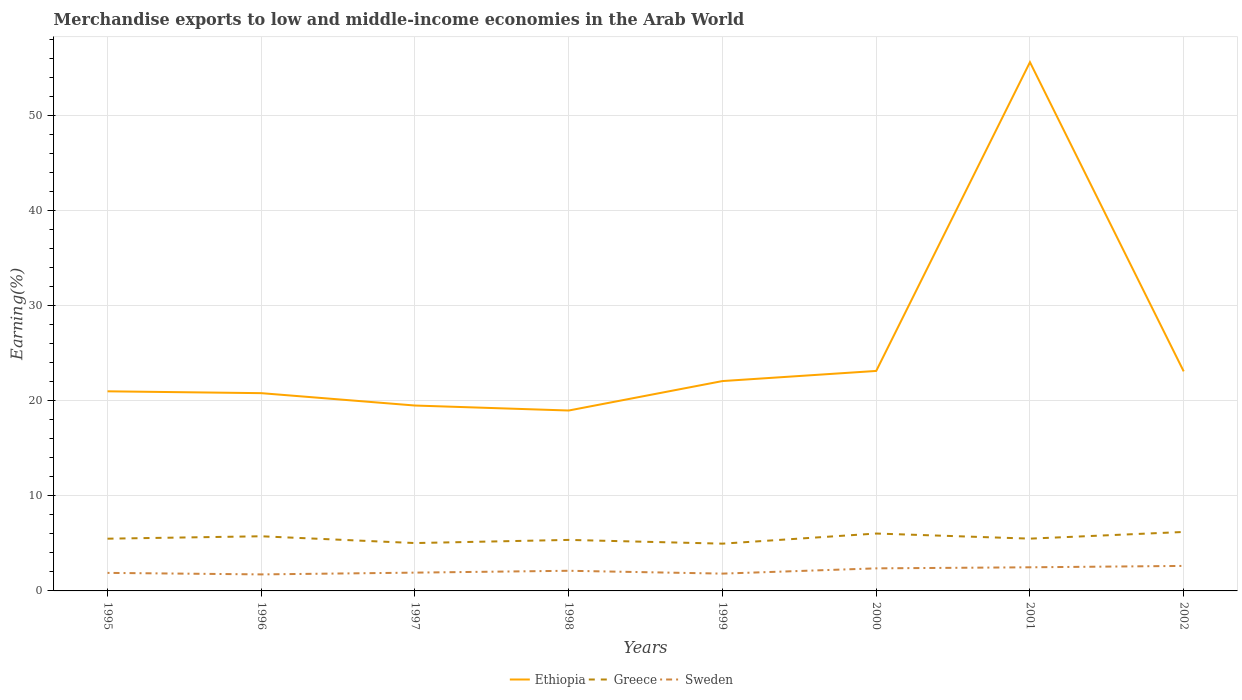Is the number of lines equal to the number of legend labels?
Make the answer very short. Yes. Across all years, what is the maximum percentage of amount earned from merchandise exports in Greece?
Give a very brief answer. 4.97. In which year was the percentage of amount earned from merchandise exports in Sweden maximum?
Ensure brevity in your answer.  1996. What is the total percentage of amount earned from merchandise exports in Sweden in the graph?
Offer a very short reply. -0.25. What is the difference between the highest and the second highest percentage of amount earned from merchandise exports in Ethiopia?
Give a very brief answer. 36.65. Is the percentage of amount earned from merchandise exports in Sweden strictly greater than the percentage of amount earned from merchandise exports in Ethiopia over the years?
Give a very brief answer. Yes. Does the graph contain any zero values?
Keep it short and to the point. No. Does the graph contain grids?
Keep it short and to the point. Yes. How many legend labels are there?
Provide a succinct answer. 3. What is the title of the graph?
Provide a short and direct response. Merchandise exports to low and middle-income economies in the Arab World. Does "Panama" appear as one of the legend labels in the graph?
Give a very brief answer. No. What is the label or title of the X-axis?
Offer a terse response. Years. What is the label or title of the Y-axis?
Offer a very short reply. Earning(%). What is the Earning(%) in Ethiopia in 1995?
Your answer should be compact. 21. What is the Earning(%) of Greece in 1995?
Offer a terse response. 5.5. What is the Earning(%) of Sweden in 1995?
Your answer should be very brief. 1.9. What is the Earning(%) in Ethiopia in 1996?
Make the answer very short. 20.81. What is the Earning(%) of Greece in 1996?
Your response must be concise. 5.75. What is the Earning(%) in Sweden in 1996?
Your response must be concise. 1.74. What is the Earning(%) of Ethiopia in 1997?
Provide a short and direct response. 19.51. What is the Earning(%) in Greece in 1997?
Offer a terse response. 5.04. What is the Earning(%) of Sweden in 1997?
Offer a terse response. 1.93. What is the Earning(%) in Ethiopia in 1998?
Keep it short and to the point. 18.98. What is the Earning(%) in Greece in 1998?
Give a very brief answer. 5.37. What is the Earning(%) of Sweden in 1998?
Provide a short and direct response. 2.12. What is the Earning(%) of Ethiopia in 1999?
Your answer should be compact. 22.08. What is the Earning(%) of Greece in 1999?
Offer a terse response. 4.97. What is the Earning(%) of Sweden in 1999?
Offer a terse response. 1.82. What is the Earning(%) in Ethiopia in 2000?
Keep it short and to the point. 23.15. What is the Earning(%) in Greece in 2000?
Provide a succinct answer. 6.04. What is the Earning(%) in Sweden in 2000?
Ensure brevity in your answer.  2.37. What is the Earning(%) of Ethiopia in 2001?
Your answer should be very brief. 55.64. What is the Earning(%) of Greece in 2001?
Provide a succinct answer. 5.5. What is the Earning(%) of Sweden in 2001?
Provide a short and direct response. 2.49. What is the Earning(%) of Ethiopia in 2002?
Your response must be concise. 23.1. What is the Earning(%) in Greece in 2002?
Offer a terse response. 6.2. What is the Earning(%) of Sweden in 2002?
Ensure brevity in your answer.  2.63. Across all years, what is the maximum Earning(%) of Ethiopia?
Keep it short and to the point. 55.64. Across all years, what is the maximum Earning(%) in Greece?
Your answer should be compact. 6.2. Across all years, what is the maximum Earning(%) of Sweden?
Provide a succinct answer. 2.63. Across all years, what is the minimum Earning(%) of Ethiopia?
Provide a short and direct response. 18.98. Across all years, what is the minimum Earning(%) in Greece?
Offer a very short reply. 4.97. Across all years, what is the minimum Earning(%) in Sweden?
Offer a terse response. 1.74. What is the total Earning(%) of Ethiopia in the graph?
Make the answer very short. 204.28. What is the total Earning(%) of Greece in the graph?
Your answer should be very brief. 44.37. What is the total Earning(%) of Sweden in the graph?
Your answer should be very brief. 17. What is the difference between the Earning(%) of Ethiopia in 1995 and that in 1996?
Provide a succinct answer. 0.19. What is the difference between the Earning(%) of Greece in 1995 and that in 1996?
Provide a succinct answer. -0.25. What is the difference between the Earning(%) of Sweden in 1995 and that in 1996?
Keep it short and to the point. 0.16. What is the difference between the Earning(%) in Ethiopia in 1995 and that in 1997?
Keep it short and to the point. 1.5. What is the difference between the Earning(%) of Greece in 1995 and that in 1997?
Offer a very short reply. 0.46. What is the difference between the Earning(%) of Sweden in 1995 and that in 1997?
Give a very brief answer. -0.03. What is the difference between the Earning(%) in Ethiopia in 1995 and that in 1998?
Your response must be concise. 2.02. What is the difference between the Earning(%) in Greece in 1995 and that in 1998?
Keep it short and to the point. 0.13. What is the difference between the Earning(%) in Sweden in 1995 and that in 1998?
Your response must be concise. -0.22. What is the difference between the Earning(%) of Ethiopia in 1995 and that in 1999?
Keep it short and to the point. -1.08. What is the difference between the Earning(%) of Greece in 1995 and that in 1999?
Ensure brevity in your answer.  0.52. What is the difference between the Earning(%) of Sweden in 1995 and that in 1999?
Provide a succinct answer. 0.08. What is the difference between the Earning(%) in Ethiopia in 1995 and that in 2000?
Make the answer very short. -2.14. What is the difference between the Earning(%) in Greece in 1995 and that in 2000?
Offer a very short reply. -0.54. What is the difference between the Earning(%) in Sweden in 1995 and that in 2000?
Offer a terse response. -0.48. What is the difference between the Earning(%) in Ethiopia in 1995 and that in 2001?
Ensure brevity in your answer.  -34.63. What is the difference between the Earning(%) of Greece in 1995 and that in 2001?
Your response must be concise. -0. What is the difference between the Earning(%) in Sweden in 1995 and that in 2001?
Keep it short and to the point. -0.59. What is the difference between the Earning(%) of Ethiopia in 1995 and that in 2002?
Offer a terse response. -2.1. What is the difference between the Earning(%) of Greece in 1995 and that in 2002?
Offer a very short reply. -0.71. What is the difference between the Earning(%) in Sweden in 1995 and that in 2002?
Your response must be concise. -0.73. What is the difference between the Earning(%) in Ethiopia in 1996 and that in 1997?
Provide a short and direct response. 1.3. What is the difference between the Earning(%) in Greece in 1996 and that in 1997?
Your answer should be compact. 0.71. What is the difference between the Earning(%) in Sweden in 1996 and that in 1997?
Keep it short and to the point. -0.19. What is the difference between the Earning(%) in Ethiopia in 1996 and that in 1998?
Offer a very short reply. 1.83. What is the difference between the Earning(%) in Greece in 1996 and that in 1998?
Make the answer very short. 0.38. What is the difference between the Earning(%) of Sweden in 1996 and that in 1998?
Give a very brief answer. -0.38. What is the difference between the Earning(%) in Ethiopia in 1996 and that in 1999?
Your answer should be very brief. -1.27. What is the difference between the Earning(%) of Greece in 1996 and that in 1999?
Your response must be concise. 0.78. What is the difference between the Earning(%) in Sweden in 1996 and that in 1999?
Give a very brief answer. -0.08. What is the difference between the Earning(%) in Ethiopia in 1996 and that in 2000?
Your answer should be very brief. -2.34. What is the difference between the Earning(%) in Greece in 1996 and that in 2000?
Keep it short and to the point. -0.29. What is the difference between the Earning(%) in Sweden in 1996 and that in 2000?
Your answer should be compact. -0.64. What is the difference between the Earning(%) of Ethiopia in 1996 and that in 2001?
Give a very brief answer. -34.83. What is the difference between the Earning(%) in Greece in 1996 and that in 2001?
Provide a succinct answer. 0.25. What is the difference between the Earning(%) in Sweden in 1996 and that in 2001?
Make the answer very short. -0.75. What is the difference between the Earning(%) in Ethiopia in 1996 and that in 2002?
Provide a succinct answer. -2.29. What is the difference between the Earning(%) of Greece in 1996 and that in 2002?
Ensure brevity in your answer.  -0.45. What is the difference between the Earning(%) of Sweden in 1996 and that in 2002?
Provide a short and direct response. -0.89. What is the difference between the Earning(%) of Ethiopia in 1997 and that in 1998?
Your response must be concise. 0.52. What is the difference between the Earning(%) in Greece in 1997 and that in 1998?
Give a very brief answer. -0.33. What is the difference between the Earning(%) of Sweden in 1997 and that in 1998?
Ensure brevity in your answer.  -0.2. What is the difference between the Earning(%) in Ethiopia in 1997 and that in 1999?
Ensure brevity in your answer.  -2.57. What is the difference between the Earning(%) in Greece in 1997 and that in 1999?
Offer a very short reply. 0.06. What is the difference between the Earning(%) in Sweden in 1997 and that in 1999?
Your answer should be very brief. 0.1. What is the difference between the Earning(%) in Ethiopia in 1997 and that in 2000?
Give a very brief answer. -3.64. What is the difference between the Earning(%) of Greece in 1997 and that in 2000?
Offer a terse response. -1. What is the difference between the Earning(%) of Sweden in 1997 and that in 2000?
Keep it short and to the point. -0.45. What is the difference between the Earning(%) in Ethiopia in 1997 and that in 2001?
Ensure brevity in your answer.  -36.13. What is the difference between the Earning(%) of Greece in 1997 and that in 2001?
Provide a succinct answer. -0.47. What is the difference between the Earning(%) in Sweden in 1997 and that in 2001?
Your answer should be compact. -0.56. What is the difference between the Earning(%) in Ethiopia in 1997 and that in 2002?
Your response must be concise. -3.59. What is the difference between the Earning(%) of Greece in 1997 and that in 2002?
Make the answer very short. -1.17. What is the difference between the Earning(%) in Sweden in 1997 and that in 2002?
Your answer should be very brief. -0.71. What is the difference between the Earning(%) of Ethiopia in 1998 and that in 1999?
Provide a short and direct response. -3.1. What is the difference between the Earning(%) in Greece in 1998 and that in 1999?
Provide a short and direct response. 0.4. What is the difference between the Earning(%) of Sweden in 1998 and that in 1999?
Provide a short and direct response. 0.3. What is the difference between the Earning(%) in Ethiopia in 1998 and that in 2000?
Your answer should be very brief. -4.16. What is the difference between the Earning(%) of Greece in 1998 and that in 2000?
Your answer should be compact. -0.67. What is the difference between the Earning(%) of Sweden in 1998 and that in 2000?
Offer a terse response. -0.25. What is the difference between the Earning(%) of Ethiopia in 1998 and that in 2001?
Your response must be concise. -36.65. What is the difference between the Earning(%) of Greece in 1998 and that in 2001?
Your answer should be compact. -0.13. What is the difference between the Earning(%) of Sweden in 1998 and that in 2001?
Your answer should be very brief. -0.37. What is the difference between the Earning(%) in Ethiopia in 1998 and that in 2002?
Give a very brief answer. -4.12. What is the difference between the Earning(%) in Greece in 1998 and that in 2002?
Provide a short and direct response. -0.84. What is the difference between the Earning(%) in Sweden in 1998 and that in 2002?
Offer a terse response. -0.51. What is the difference between the Earning(%) in Ethiopia in 1999 and that in 2000?
Provide a succinct answer. -1.07. What is the difference between the Earning(%) of Greece in 1999 and that in 2000?
Keep it short and to the point. -1.07. What is the difference between the Earning(%) in Sweden in 1999 and that in 2000?
Make the answer very short. -0.55. What is the difference between the Earning(%) of Ethiopia in 1999 and that in 2001?
Offer a terse response. -33.56. What is the difference between the Earning(%) of Greece in 1999 and that in 2001?
Keep it short and to the point. -0.53. What is the difference between the Earning(%) in Sweden in 1999 and that in 2001?
Keep it short and to the point. -0.67. What is the difference between the Earning(%) of Ethiopia in 1999 and that in 2002?
Your response must be concise. -1.02. What is the difference between the Earning(%) of Greece in 1999 and that in 2002?
Give a very brief answer. -1.23. What is the difference between the Earning(%) of Sweden in 1999 and that in 2002?
Offer a very short reply. -0.81. What is the difference between the Earning(%) in Ethiopia in 2000 and that in 2001?
Keep it short and to the point. -32.49. What is the difference between the Earning(%) of Greece in 2000 and that in 2001?
Make the answer very short. 0.54. What is the difference between the Earning(%) of Sweden in 2000 and that in 2001?
Your response must be concise. -0.11. What is the difference between the Earning(%) in Ethiopia in 2000 and that in 2002?
Provide a succinct answer. 0.05. What is the difference between the Earning(%) in Greece in 2000 and that in 2002?
Provide a succinct answer. -0.17. What is the difference between the Earning(%) of Sweden in 2000 and that in 2002?
Keep it short and to the point. -0.26. What is the difference between the Earning(%) in Ethiopia in 2001 and that in 2002?
Make the answer very short. 32.53. What is the difference between the Earning(%) in Greece in 2001 and that in 2002?
Give a very brief answer. -0.7. What is the difference between the Earning(%) of Sweden in 2001 and that in 2002?
Give a very brief answer. -0.15. What is the difference between the Earning(%) in Ethiopia in 1995 and the Earning(%) in Greece in 1996?
Offer a very short reply. 15.25. What is the difference between the Earning(%) in Ethiopia in 1995 and the Earning(%) in Sweden in 1996?
Offer a very short reply. 19.27. What is the difference between the Earning(%) in Greece in 1995 and the Earning(%) in Sweden in 1996?
Offer a very short reply. 3.76. What is the difference between the Earning(%) of Ethiopia in 1995 and the Earning(%) of Greece in 1997?
Your answer should be very brief. 15.97. What is the difference between the Earning(%) of Ethiopia in 1995 and the Earning(%) of Sweden in 1997?
Your answer should be compact. 19.08. What is the difference between the Earning(%) in Greece in 1995 and the Earning(%) in Sweden in 1997?
Give a very brief answer. 3.57. What is the difference between the Earning(%) in Ethiopia in 1995 and the Earning(%) in Greece in 1998?
Your answer should be compact. 15.64. What is the difference between the Earning(%) of Ethiopia in 1995 and the Earning(%) of Sweden in 1998?
Give a very brief answer. 18.88. What is the difference between the Earning(%) of Greece in 1995 and the Earning(%) of Sweden in 1998?
Your response must be concise. 3.38. What is the difference between the Earning(%) of Ethiopia in 1995 and the Earning(%) of Greece in 1999?
Keep it short and to the point. 16.03. What is the difference between the Earning(%) in Ethiopia in 1995 and the Earning(%) in Sweden in 1999?
Give a very brief answer. 19.18. What is the difference between the Earning(%) of Greece in 1995 and the Earning(%) of Sweden in 1999?
Your response must be concise. 3.68. What is the difference between the Earning(%) of Ethiopia in 1995 and the Earning(%) of Greece in 2000?
Give a very brief answer. 14.96. What is the difference between the Earning(%) in Ethiopia in 1995 and the Earning(%) in Sweden in 2000?
Provide a succinct answer. 18.63. What is the difference between the Earning(%) of Greece in 1995 and the Earning(%) of Sweden in 2000?
Your answer should be very brief. 3.12. What is the difference between the Earning(%) in Ethiopia in 1995 and the Earning(%) in Greece in 2001?
Your response must be concise. 15.5. What is the difference between the Earning(%) in Ethiopia in 1995 and the Earning(%) in Sweden in 2001?
Provide a short and direct response. 18.52. What is the difference between the Earning(%) of Greece in 1995 and the Earning(%) of Sweden in 2001?
Your answer should be compact. 3.01. What is the difference between the Earning(%) in Ethiopia in 1995 and the Earning(%) in Greece in 2002?
Offer a very short reply. 14.8. What is the difference between the Earning(%) of Ethiopia in 1995 and the Earning(%) of Sweden in 2002?
Ensure brevity in your answer.  18.37. What is the difference between the Earning(%) of Greece in 1995 and the Earning(%) of Sweden in 2002?
Your answer should be compact. 2.87. What is the difference between the Earning(%) in Ethiopia in 1996 and the Earning(%) in Greece in 1997?
Keep it short and to the point. 15.77. What is the difference between the Earning(%) in Ethiopia in 1996 and the Earning(%) in Sweden in 1997?
Your answer should be compact. 18.89. What is the difference between the Earning(%) in Greece in 1996 and the Earning(%) in Sweden in 1997?
Keep it short and to the point. 3.83. What is the difference between the Earning(%) in Ethiopia in 1996 and the Earning(%) in Greece in 1998?
Provide a succinct answer. 15.44. What is the difference between the Earning(%) in Ethiopia in 1996 and the Earning(%) in Sweden in 1998?
Provide a short and direct response. 18.69. What is the difference between the Earning(%) in Greece in 1996 and the Earning(%) in Sweden in 1998?
Provide a succinct answer. 3.63. What is the difference between the Earning(%) of Ethiopia in 1996 and the Earning(%) of Greece in 1999?
Offer a terse response. 15.84. What is the difference between the Earning(%) in Ethiopia in 1996 and the Earning(%) in Sweden in 1999?
Keep it short and to the point. 18.99. What is the difference between the Earning(%) in Greece in 1996 and the Earning(%) in Sweden in 1999?
Keep it short and to the point. 3.93. What is the difference between the Earning(%) of Ethiopia in 1996 and the Earning(%) of Greece in 2000?
Your answer should be very brief. 14.77. What is the difference between the Earning(%) of Ethiopia in 1996 and the Earning(%) of Sweden in 2000?
Your answer should be compact. 18.44. What is the difference between the Earning(%) of Greece in 1996 and the Earning(%) of Sweden in 2000?
Offer a very short reply. 3.38. What is the difference between the Earning(%) in Ethiopia in 1996 and the Earning(%) in Greece in 2001?
Keep it short and to the point. 15.31. What is the difference between the Earning(%) in Ethiopia in 1996 and the Earning(%) in Sweden in 2001?
Ensure brevity in your answer.  18.32. What is the difference between the Earning(%) of Greece in 1996 and the Earning(%) of Sweden in 2001?
Your answer should be very brief. 3.26. What is the difference between the Earning(%) of Ethiopia in 1996 and the Earning(%) of Greece in 2002?
Offer a very short reply. 14.61. What is the difference between the Earning(%) of Ethiopia in 1996 and the Earning(%) of Sweden in 2002?
Your answer should be compact. 18.18. What is the difference between the Earning(%) in Greece in 1996 and the Earning(%) in Sweden in 2002?
Ensure brevity in your answer.  3.12. What is the difference between the Earning(%) in Ethiopia in 1997 and the Earning(%) in Greece in 1998?
Give a very brief answer. 14.14. What is the difference between the Earning(%) of Ethiopia in 1997 and the Earning(%) of Sweden in 1998?
Provide a succinct answer. 17.39. What is the difference between the Earning(%) in Greece in 1997 and the Earning(%) in Sweden in 1998?
Your response must be concise. 2.92. What is the difference between the Earning(%) of Ethiopia in 1997 and the Earning(%) of Greece in 1999?
Make the answer very short. 14.54. What is the difference between the Earning(%) in Ethiopia in 1997 and the Earning(%) in Sweden in 1999?
Make the answer very short. 17.69. What is the difference between the Earning(%) of Greece in 1997 and the Earning(%) of Sweden in 1999?
Provide a short and direct response. 3.22. What is the difference between the Earning(%) in Ethiopia in 1997 and the Earning(%) in Greece in 2000?
Provide a short and direct response. 13.47. What is the difference between the Earning(%) in Ethiopia in 1997 and the Earning(%) in Sweden in 2000?
Offer a terse response. 17.13. What is the difference between the Earning(%) of Greece in 1997 and the Earning(%) of Sweden in 2000?
Give a very brief answer. 2.66. What is the difference between the Earning(%) of Ethiopia in 1997 and the Earning(%) of Greece in 2001?
Ensure brevity in your answer.  14.01. What is the difference between the Earning(%) in Ethiopia in 1997 and the Earning(%) in Sweden in 2001?
Your answer should be compact. 17.02. What is the difference between the Earning(%) of Greece in 1997 and the Earning(%) of Sweden in 2001?
Give a very brief answer. 2.55. What is the difference between the Earning(%) of Ethiopia in 1997 and the Earning(%) of Greece in 2002?
Provide a short and direct response. 13.3. What is the difference between the Earning(%) of Ethiopia in 1997 and the Earning(%) of Sweden in 2002?
Keep it short and to the point. 16.88. What is the difference between the Earning(%) of Greece in 1997 and the Earning(%) of Sweden in 2002?
Make the answer very short. 2.4. What is the difference between the Earning(%) of Ethiopia in 1998 and the Earning(%) of Greece in 1999?
Offer a very short reply. 14.01. What is the difference between the Earning(%) of Ethiopia in 1998 and the Earning(%) of Sweden in 1999?
Provide a short and direct response. 17.16. What is the difference between the Earning(%) of Greece in 1998 and the Earning(%) of Sweden in 1999?
Keep it short and to the point. 3.55. What is the difference between the Earning(%) of Ethiopia in 1998 and the Earning(%) of Greece in 2000?
Offer a terse response. 12.94. What is the difference between the Earning(%) in Ethiopia in 1998 and the Earning(%) in Sweden in 2000?
Give a very brief answer. 16.61. What is the difference between the Earning(%) of Greece in 1998 and the Earning(%) of Sweden in 2000?
Provide a succinct answer. 2.99. What is the difference between the Earning(%) of Ethiopia in 1998 and the Earning(%) of Greece in 2001?
Your answer should be compact. 13.48. What is the difference between the Earning(%) of Ethiopia in 1998 and the Earning(%) of Sweden in 2001?
Provide a short and direct response. 16.5. What is the difference between the Earning(%) in Greece in 1998 and the Earning(%) in Sweden in 2001?
Your answer should be compact. 2.88. What is the difference between the Earning(%) of Ethiopia in 1998 and the Earning(%) of Greece in 2002?
Keep it short and to the point. 12.78. What is the difference between the Earning(%) of Ethiopia in 1998 and the Earning(%) of Sweden in 2002?
Give a very brief answer. 16.35. What is the difference between the Earning(%) in Greece in 1998 and the Earning(%) in Sweden in 2002?
Ensure brevity in your answer.  2.74. What is the difference between the Earning(%) in Ethiopia in 1999 and the Earning(%) in Greece in 2000?
Your answer should be very brief. 16.04. What is the difference between the Earning(%) of Ethiopia in 1999 and the Earning(%) of Sweden in 2000?
Your answer should be compact. 19.71. What is the difference between the Earning(%) in Greece in 1999 and the Earning(%) in Sweden in 2000?
Provide a short and direct response. 2.6. What is the difference between the Earning(%) of Ethiopia in 1999 and the Earning(%) of Greece in 2001?
Keep it short and to the point. 16.58. What is the difference between the Earning(%) of Ethiopia in 1999 and the Earning(%) of Sweden in 2001?
Provide a short and direct response. 19.6. What is the difference between the Earning(%) in Greece in 1999 and the Earning(%) in Sweden in 2001?
Your answer should be very brief. 2.49. What is the difference between the Earning(%) of Ethiopia in 1999 and the Earning(%) of Greece in 2002?
Offer a very short reply. 15.88. What is the difference between the Earning(%) of Ethiopia in 1999 and the Earning(%) of Sweden in 2002?
Keep it short and to the point. 19.45. What is the difference between the Earning(%) of Greece in 1999 and the Earning(%) of Sweden in 2002?
Your answer should be very brief. 2.34. What is the difference between the Earning(%) of Ethiopia in 2000 and the Earning(%) of Greece in 2001?
Offer a terse response. 17.65. What is the difference between the Earning(%) in Ethiopia in 2000 and the Earning(%) in Sweden in 2001?
Your response must be concise. 20.66. What is the difference between the Earning(%) in Greece in 2000 and the Earning(%) in Sweden in 2001?
Offer a terse response. 3.55. What is the difference between the Earning(%) in Ethiopia in 2000 and the Earning(%) in Greece in 2002?
Provide a succinct answer. 16.94. What is the difference between the Earning(%) in Ethiopia in 2000 and the Earning(%) in Sweden in 2002?
Your response must be concise. 20.52. What is the difference between the Earning(%) of Greece in 2000 and the Earning(%) of Sweden in 2002?
Offer a very short reply. 3.41. What is the difference between the Earning(%) of Ethiopia in 2001 and the Earning(%) of Greece in 2002?
Provide a short and direct response. 49.43. What is the difference between the Earning(%) of Ethiopia in 2001 and the Earning(%) of Sweden in 2002?
Your response must be concise. 53.01. What is the difference between the Earning(%) of Greece in 2001 and the Earning(%) of Sweden in 2002?
Make the answer very short. 2.87. What is the average Earning(%) of Ethiopia per year?
Your response must be concise. 25.54. What is the average Earning(%) in Greece per year?
Provide a short and direct response. 5.55. What is the average Earning(%) of Sweden per year?
Provide a succinct answer. 2.12. In the year 1995, what is the difference between the Earning(%) in Ethiopia and Earning(%) in Greece?
Offer a terse response. 15.51. In the year 1995, what is the difference between the Earning(%) of Ethiopia and Earning(%) of Sweden?
Make the answer very short. 19.11. In the year 1995, what is the difference between the Earning(%) of Greece and Earning(%) of Sweden?
Offer a very short reply. 3.6. In the year 1996, what is the difference between the Earning(%) in Ethiopia and Earning(%) in Greece?
Provide a short and direct response. 15.06. In the year 1996, what is the difference between the Earning(%) of Ethiopia and Earning(%) of Sweden?
Your answer should be very brief. 19.07. In the year 1996, what is the difference between the Earning(%) of Greece and Earning(%) of Sweden?
Your response must be concise. 4.01. In the year 1997, what is the difference between the Earning(%) of Ethiopia and Earning(%) of Greece?
Provide a short and direct response. 14.47. In the year 1997, what is the difference between the Earning(%) in Ethiopia and Earning(%) in Sweden?
Offer a very short reply. 17.58. In the year 1997, what is the difference between the Earning(%) in Greece and Earning(%) in Sweden?
Ensure brevity in your answer.  3.11. In the year 1998, what is the difference between the Earning(%) of Ethiopia and Earning(%) of Greece?
Keep it short and to the point. 13.62. In the year 1998, what is the difference between the Earning(%) of Ethiopia and Earning(%) of Sweden?
Offer a very short reply. 16.86. In the year 1998, what is the difference between the Earning(%) of Greece and Earning(%) of Sweden?
Your answer should be compact. 3.25. In the year 1999, what is the difference between the Earning(%) in Ethiopia and Earning(%) in Greece?
Offer a terse response. 17.11. In the year 1999, what is the difference between the Earning(%) of Ethiopia and Earning(%) of Sweden?
Make the answer very short. 20.26. In the year 1999, what is the difference between the Earning(%) in Greece and Earning(%) in Sweden?
Your answer should be very brief. 3.15. In the year 2000, what is the difference between the Earning(%) of Ethiopia and Earning(%) of Greece?
Ensure brevity in your answer.  17.11. In the year 2000, what is the difference between the Earning(%) of Ethiopia and Earning(%) of Sweden?
Provide a succinct answer. 20.77. In the year 2000, what is the difference between the Earning(%) of Greece and Earning(%) of Sweden?
Keep it short and to the point. 3.66. In the year 2001, what is the difference between the Earning(%) of Ethiopia and Earning(%) of Greece?
Your response must be concise. 50.14. In the year 2001, what is the difference between the Earning(%) in Ethiopia and Earning(%) in Sweden?
Give a very brief answer. 53.15. In the year 2001, what is the difference between the Earning(%) of Greece and Earning(%) of Sweden?
Your answer should be very brief. 3.02. In the year 2002, what is the difference between the Earning(%) in Ethiopia and Earning(%) in Greece?
Offer a very short reply. 16.9. In the year 2002, what is the difference between the Earning(%) of Ethiopia and Earning(%) of Sweden?
Your answer should be very brief. 20.47. In the year 2002, what is the difference between the Earning(%) of Greece and Earning(%) of Sweden?
Your response must be concise. 3.57. What is the ratio of the Earning(%) in Ethiopia in 1995 to that in 1996?
Provide a short and direct response. 1.01. What is the ratio of the Earning(%) of Greece in 1995 to that in 1996?
Offer a very short reply. 0.96. What is the ratio of the Earning(%) of Sweden in 1995 to that in 1996?
Keep it short and to the point. 1.09. What is the ratio of the Earning(%) in Ethiopia in 1995 to that in 1997?
Provide a short and direct response. 1.08. What is the ratio of the Earning(%) in Greece in 1995 to that in 1997?
Your answer should be compact. 1.09. What is the ratio of the Earning(%) of Sweden in 1995 to that in 1997?
Your answer should be compact. 0.99. What is the ratio of the Earning(%) of Ethiopia in 1995 to that in 1998?
Your response must be concise. 1.11. What is the ratio of the Earning(%) in Greece in 1995 to that in 1998?
Provide a succinct answer. 1.02. What is the ratio of the Earning(%) of Sweden in 1995 to that in 1998?
Give a very brief answer. 0.9. What is the ratio of the Earning(%) of Ethiopia in 1995 to that in 1999?
Keep it short and to the point. 0.95. What is the ratio of the Earning(%) of Greece in 1995 to that in 1999?
Make the answer very short. 1.11. What is the ratio of the Earning(%) of Sweden in 1995 to that in 1999?
Offer a terse response. 1.04. What is the ratio of the Earning(%) of Ethiopia in 1995 to that in 2000?
Make the answer very short. 0.91. What is the ratio of the Earning(%) in Greece in 1995 to that in 2000?
Make the answer very short. 0.91. What is the ratio of the Earning(%) in Sweden in 1995 to that in 2000?
Give a very brief answer. 0.8. What is the ratio of the Earning(%) of Ethiopia in 1995 to that in 2001?
Your answer should be very brief. 0.38. What is the ratio of the Earning(%) of Greece in 1995 to that in 2001?
Make the answer very short. 1. What is the ratio of the Earning(%) in Sweden in 1995 to that in 2001?
Your answer should be compact. 0.76. What is the ratio of the Earning(%) of Ethiopia in 1995 to that in 2002?
Ensure brevity in your answer.  0.91. What is the ratio of the Earning(%) of Greece in 1995 to that in 2002?
Your answer should be compact. 0.89. What is the ratio of the Earning(%) of Sweden in 1995 to that in 2002?
Offer a terse response. 0.72. What is the ratio of the Earning(%) of Ethiopia in 1996 to that in 1997?
Provide a short and direct response. 1.07. What is the ratio of the Earning(%) in Greece in 1996 to that in 1997?
Keep it short and to the point. 1.14. What is the ratio of the Earning(%) in Sweden in 1996 to that in 1997?
Keep it short and to the point. 0.9. What is the ratio of the Earning(%) of Ethiopia in 1996 to that in 1998?
Your answer should be compact. 1.1. What is the ratio of the Earning(%) of Greece in 1996 to that in 1998?
Ensure brevity in your answer.  1.07. What is the ratio of the Earning(%) of Sweden in 1996 to that in 1998?
Make the answer very short. 0.82. What is the ratio of the Earning(%) in Ethiopia in 1996 to that in 1999?
Your response must be concise. 0.94. What is the ratio of the Earning(%) of Greece in 1996 to that in 1999?
Ensure brevity in your answer.  1.16. What is the ratio of the Earning(%) in Sweden in 1996 to that in 1999?
Ensure brevity in your answer.  0.95. What is the ratio of the Earning(%) of Ethiopia in 1996 to that in 2000?
Offer a terse response. 0.9. What is the ratio of the Earning(%) of Greece in 1996 to that in 2000?
Your answer should be very brief. 0.95. What is the ratio of the Earning(%) in Sweden in 1996 to that in 2000?
Provide a short and direct response. 0.73. What is the ratio of the Earning(%) of Ethiopia in 1996 to that in 2001?
Offer a very short reply. 0.37. What is the ratio of the Earning(%) of Greece in 1996 to that in 2001?
Keep it short and to the point. 1.05. What is the ratio of the Earning(%) of Sweden in 1996 to that in 2001?
Give a very brief answer. 0.7. What is the ratio of the Earning(%) of Ethiopia in 1996 to that in 2002?
Ensure brevity in your answer.  0.9. What is the ratio of the Earning(%) in Greece in 1996 to that in 2002?
Provide a succinct answer. 0.93. What is the ratio of the Earning(%) in Sweden in 1996 to that in 2002?
Make the answer very short. 0.66. What is the ratio of the Earning(%) of Ethiopia in 1997 to that in 1998?
Give a very brief answer. 1.03. What is the ratio of the Earning(%) of Greece in 1997 to that in 1998?
Keep it short and to the point. 0.94. What is the ratio of the Earning(%) of Sweden in 1997 to that in 1998?
Give a very brief answer. 0.91. What is the ratio of the Earning(%) of Ethiopia in 1997 to that in 1999?
Your answer should be very brief. 0.88. What is the ratio of the Earning(%) in Greece in 1997 to that in 1999?
Ensure brevity in your answer.  1.01. What is the ratio of the Earning(%) of Sweden in 1997 to that in 1999?
Your answer should be very brief. 1.06. What is the ratio of the Earning(%) in Ethiopia in 1997 to that in 2000?
Provide a succinct answer. 0.84. What is the ratio of the Earning(%) in Greece in 1997 to that in 2000?
Give a very brief answer. 0.83. What is the ratio of the Earning(%) in Sweden in 1997 to that in 2000?
Provide a short and direct response. 0.81. What is the ratio of the Earning(%) in Ethiopia in 1997 to that in 2001?
Give a very brief answer. 0.35. What is the ratio of the Earning(%) in Greece in 1997 to that in 2001?
Your response must be concise. 0.92. What is the ratio of the Earning(%) in Sweden in 1997 to that in 2001?
Your answer should be very brief. 0.77. What is the ratio of the Earning(%) of Ethiopia in 1997 to that in 2002?
Provide a succinct answer. 0.84. What is the ratio of the Earning(%) of Greece in 1997 to that in 2002?
Provide a succinct answer. 0.81. What is the ratio of the Earning(%) in Sweden in 1997 to that in 2002?
Offer a terse response. 0.73. What is the ratio of the Earning(%) of Ethiopia in 1998 to that in 1999?
Offer a very short reply. 0.86. What is the ratio of the Earning(%) of Greece in 1998 to that in 1999?
Your response must be concise. 1.08. What is the ratio of the Earning(%) in Sweden in 1998 to that in 1999?
Your answer should be compact. 1.16. What is the ratio of the Earning(%) in Ethiopia in 1998 to that in 2000?
Keep it short and to the point. 0.82. What is the ratio of the Earning(%) in Greece in 1998 to that in 2000?
Your response must be concise. 0.89. What is the ratio of the Earning(%) of Sweden in 1998 to that in 2000?
Provide a succinct answer. 0.89. What is the ratio of the Earning(%) in Ethiopia in 1998 to that in 2001?
Your answer should be compact. 0.34. What is the ratio of the Earning(%) in Greece in 1998 to that in 2001?
Your answer should be compact. 0.98. What is the ratio of the Earning(%) of Sweden in 1998 to that in 2001?
Ensure brevity in your answer.  0.85. What is the ratio of the Earning(%) in Ethiopia in 1998 to that in 2002?
Make the answer very short. 0.82. What is the ratio of the Earning(%) of Greece in 1998 to that in 2002?
Provide a succinct answer. 0.87. What is the ratio of the Earning(%) in Sweden in 1998 to that in 2002?
Offer a very short reply. 0.81. What is the ratio of the Earning(%) in Ethiopia in 1999 to that in 2000?
Make the answer very short. 0.95. What is the ratio of the Earning(%) in Greece in 1999 to that in 2000?
Keep it short and to the point. 0.82. What is the ratio of the Earning(%) in Sweden in 1999 to that in 2000?
Make the answer very short. 0.77. What is the ratio of the Earning(%) in Ethiopia in 1999 to that in 2001?
Ensure brevity in your answer.  0.4. What is the ratio of the Earning(%) in Greece in 1999 to that in 2001?
Make the answer very short. 0.9. What is the ratio of the Earning(%) in Sweden in 1999 to that in 2001?
Offer a very short reply. 0.73. What is the ratio of the Earning(%) in Ethiopia in 1999 to that in 2002?
Offer a terse response. 0.96. What is the ratio of the Earning(%) in Greece in 1999 to that in 2002?
Provide a short and direct response. 0.8. What is the ratio of the Earning(%) of Sweden in 1999 to that in 2002?
Your answer should be compact. 0.69. What is the ratio of the Earning(%) in Ethiopia in 2000 to that in 2001?
Provide a succinct answer. 0.42. What is the ratio of the Earning(%) of Greece in 2000 to that in 2001?
Provide a succinct answer. 1.1. What is the ratio of the Earning(%) of Sweden in 2000 to that in 2001?
Provide a short and direct response. 0.96. What is the ratio of the Earning(%) of Ethiopia in 2000 to that in 2002?
Give a very brief answer. 1. What is the ratio of the Earning(%) in Greece in 2000 to that in 2002?
Offer a terse response. 0.97. What is the ratio of the Earning(%) in Sweden in 2000 to that in 2002?
Offer a very short reply. 0.9. What is the ratio of the Earning(%) in Ethiopia in 2001 to that in 2002?
Offer a terse response. 2.41. What is the ratio of the Earning(%) of Greece in 2001 to that in 2002?
Your answer should be very brief. 0.89. What is the ratio of the Earning(%) of Sweden in 2001 to that in 2002?
Keep it short and to the point. 0.94. What is the difference between the highest and the second highest Earning(%) of Ethiopia?
Make the answer very short. 32.49. What is the difference between the highest and the second highest Earning(%) of Greece?
Your answer should be very brief. 0.17. What is the difference between the highest and the second highest Earning(%) of Sweden?
Give a very brief answer. 0.15. What is the difference between the highest and the lowest Earning(%) in Ethiopia?
Keep it short and to the point. 36.65. What is the difference between the highest and the lowest Earning(%) of Greece?
Provide a succinct answer. 1.23. What is the difference between the highest and the lowest Earning(%) in Sweden?
Your answer should be very brief. 0.89. 